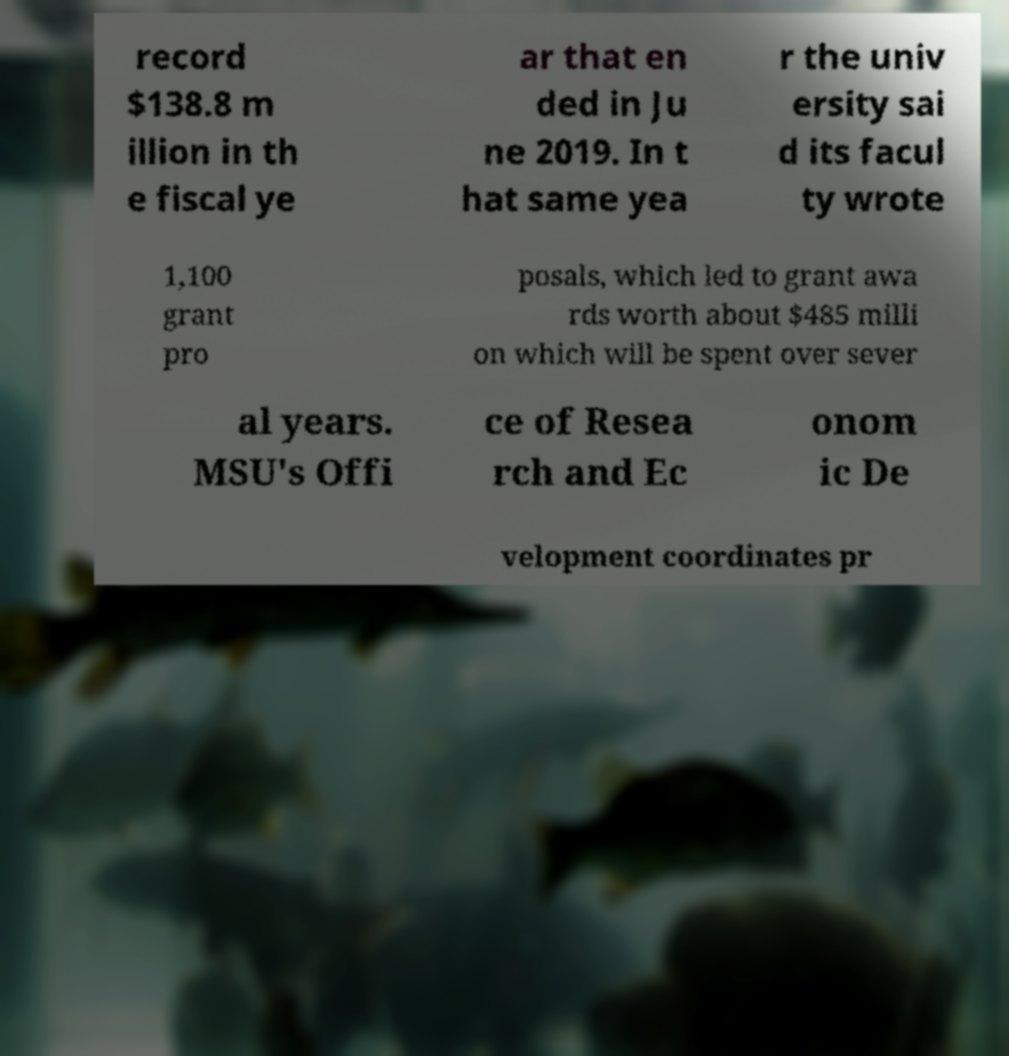Can you read and provide the text displayed in the image?This photo seems to have some interesting text. Can you extract and type it out for me? record $138.8 m illion in th e fiscal ye ar that en ded in Ju ne 2019. In t hat same yea r the univ ersity sai d its facul ty wrote 1,100 grant pro posals, which led to grant awa rds worth about $485 milli on which will be spent over sever al years. MSU's Offi ce of Resea rch and Ec onom ic De velopment coordinates pr 